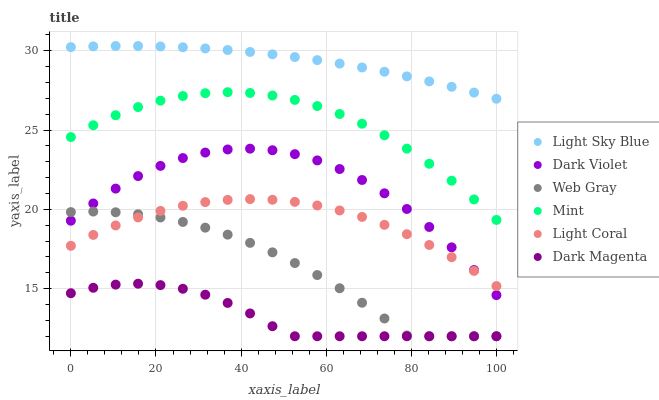Does Dark Magenta have the minimum area under the curve?
Answer yes or no. Yes. Does Light Sky Blue have the maximum area under the curve?
Answer yes or no. Yes. Does Dark Violet have the minimum area under the curve?
Answer yes or no. No. Does Dark Violet have the maximum area under the curve?
Answer yes or no. No. Is Light Sky Blue the smoothest?
Answer yes or no. Yes. Is Dark Violet the roughest?
Answer yes or no. Yes. Is Dark Magenta the smoothest?
Answer yes or no. No. Is Dark Magenta the roughest?
Answer yes or no. No. Does Web Gray have the lowest value?
Answer yes or no. Yes. Does Dark Violet have the lowest value?
Answer yes or no. No. Does Light Sky Blue have the highest value?
Answer yes or no. Yes. Does Dark Violet have the highest value?
Answer yes or no. No. Is Web Gray less than Light Sky Blue?
Answer yes or no. Yes. Is Mint greater than Dark Violet?
Answer yes or no. Yes. Does Web Gray intersect Dark Magenta?
Answer yes or no. Yes. Is Web Gray less than Dark Magenta?
Answer yes or no. No. Is Web Gray greater than Dark Magenta?
Answer yes or no. No. Does Web Gray intersect Light Sky Blue?
Answer yes or no. No. 